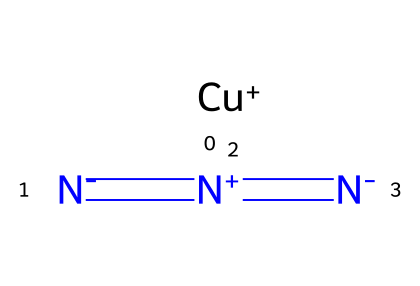What is the molecular formula of copper(I) azide? The molecular formula can be derived from the SMILES representation, which indicates one copper atom (Cu) and three nitrogen atoms (N), thus the formula is CuN3.
Answer: CuN3 How many nitrogen atoms are present in copper(I) azide? In the SMILES representation, there is a total of three nitrogen atoms, represented by the three N's in the formula.
Answer: 3 What type of bonding is primarily found in copper(I) azide? The structural formula shows multiple bonds between nitrogen atoms, specifically double bonds, indicating that there is covalent bonding between them.
Answer: covalent Does copper(I) azide contain any cation or anion? The SMILES indicates that copper is a cation (Cu+) and the nitrogen portion indicates that it is an azide ion (N3-), confirming the presence of both cation and anion.
Answer: both What is the oxidation state of copper in copper(I) azide? Copper is represented as Cu+, indicating that its oxidation state is +1 as shown by the '+' symbol in the SMILES notation of the copper atom.
Answer: +1 What type of chemical is copper(I) azide categorized under? Copper(I) azide is specifically categorized as an azide, as indicated by the presence of the azide ion (N3-) inherent to its structure.
Answer: azide What is a significant property of azides like copper(I) azide? Azides are generally known for their stability and high sensitivity, especially in relation to explosive properties, which is a distinct characteristic of this chemical family.
Answer: explosive 